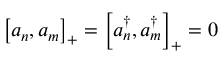Convert formula to latex. <formula><loc_0><loc_0><loc_500><loc_500>\left [ a _ { n } , a _ { m } \right ] _ { + } = \left [ a _ { n } ^ { \dagger } , a _ { m } ^ { \dagger } \right ] _ { + } = 0</formula> 